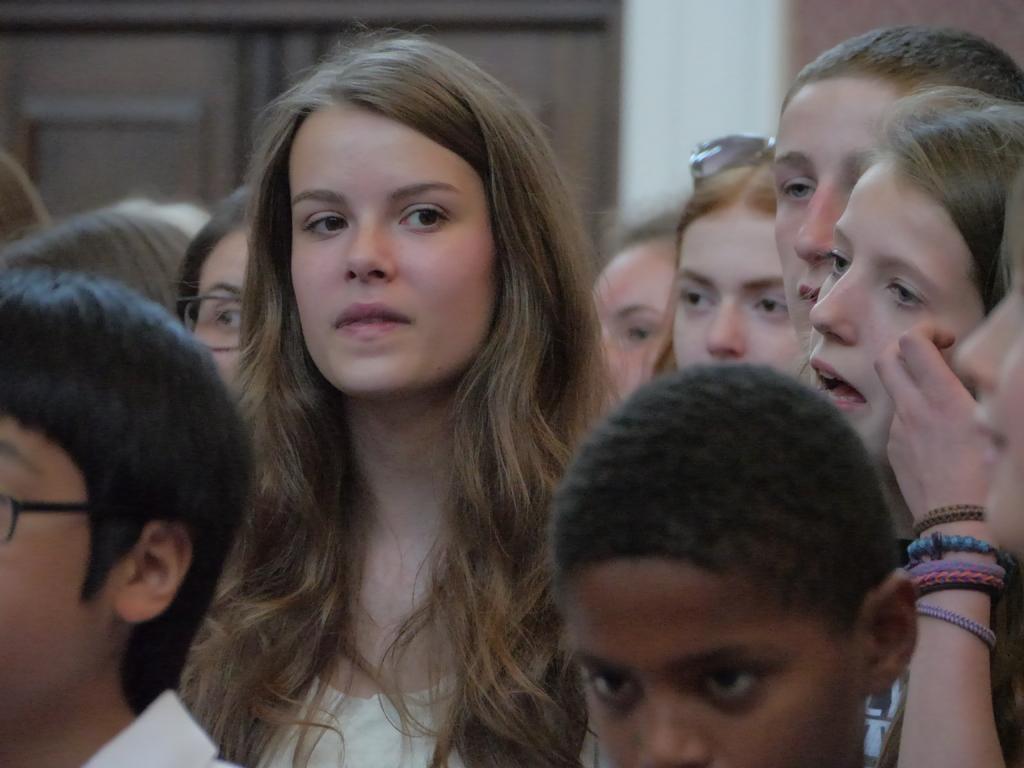Could you give a brief overview of what you see in this image? In this image I see few children and I see it is blurred in the background. 